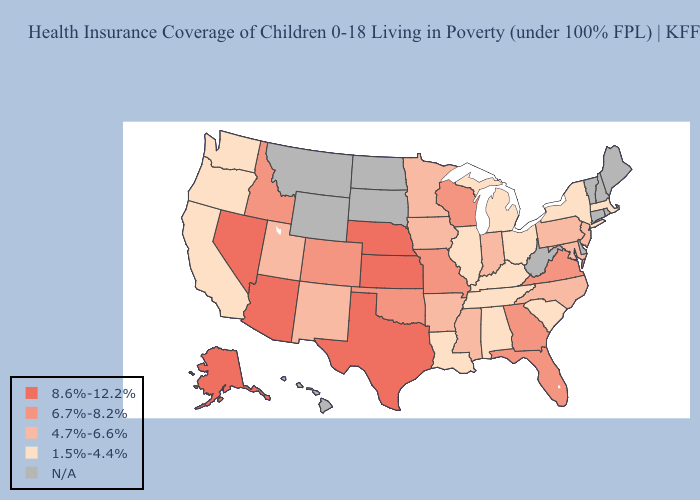Which states hav the highest value in the South?
Keep it brief. Texas. Among the states that border Wisconsin , does Minnesota have the highest value?
Give a very brief answer. Yes. Among the states that border South Dakota , does Nebraska have the lowest value?
Write a very short answer. No. What is the value of North Dakota?
Be succinct. N/A. What is the lowest value in the USA?
Quick response, please. 1.5%-4.4%. What is the value of Arizona?
Keep it brief. 8.6%-12.2%. Name the states that have a value in the range 1.5%-4.4%?
Write a very short answer. Alabama, California, Illinois, Kentucky, Louisiana, Massachusetts, Michigan, New York, Ohio, Oregon, South Carolina, Tennessee, Washington. Name the states that have a value in the range 1.5%-4.4%?
Be succinct. Alabama, California, Illinois, Kentucky, Louisiana, Massachusetts, Michigan, New York, Ohio, Oregon, South Carolina, Tennessee, Washington. Name the states that have a value in the range 4.7%-6.6%?
Write a very short answer. Arkansas, Indiana, Iowa, Maryland, Minnesota, Mississippi, New Jersey, New Mexico, North Carolina, Pennsylvania, Utah. What is the highest value in the South ?
Quick response, please. 8.6%-12.2%. What is the lowest value in states that border Illinois?
Answer briefly. 1.5%-4.4%. Does New Jersey have the highest value in the Northeast?
Be succinct. Yes. What is the lowest value in states that border Idaho?
Be succinct. 1.5%-4.4%. What is the lowest value in states that border Washington?
Answer briefly. 1.5%-4.4%. 